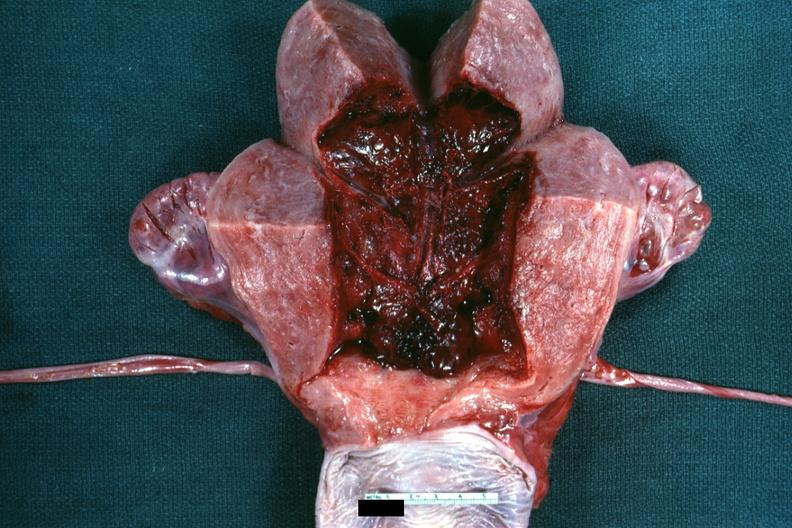what is present?
Answer the question using a single word or phrase. Female reproductive 